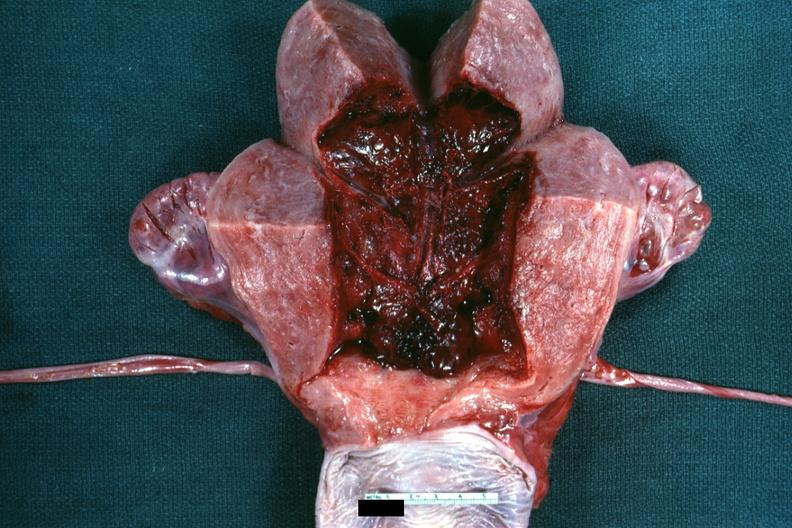what is present?
Answer the question using a single word or phrase. Female reproductive 